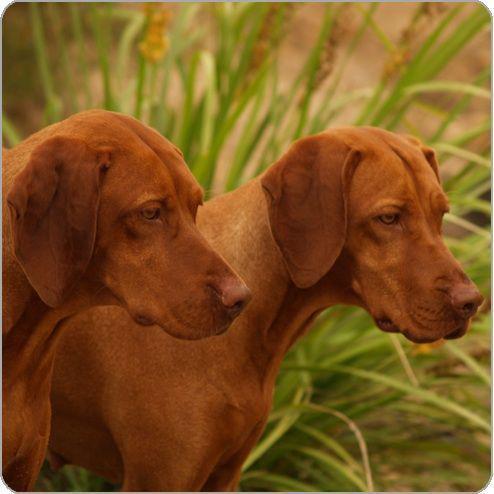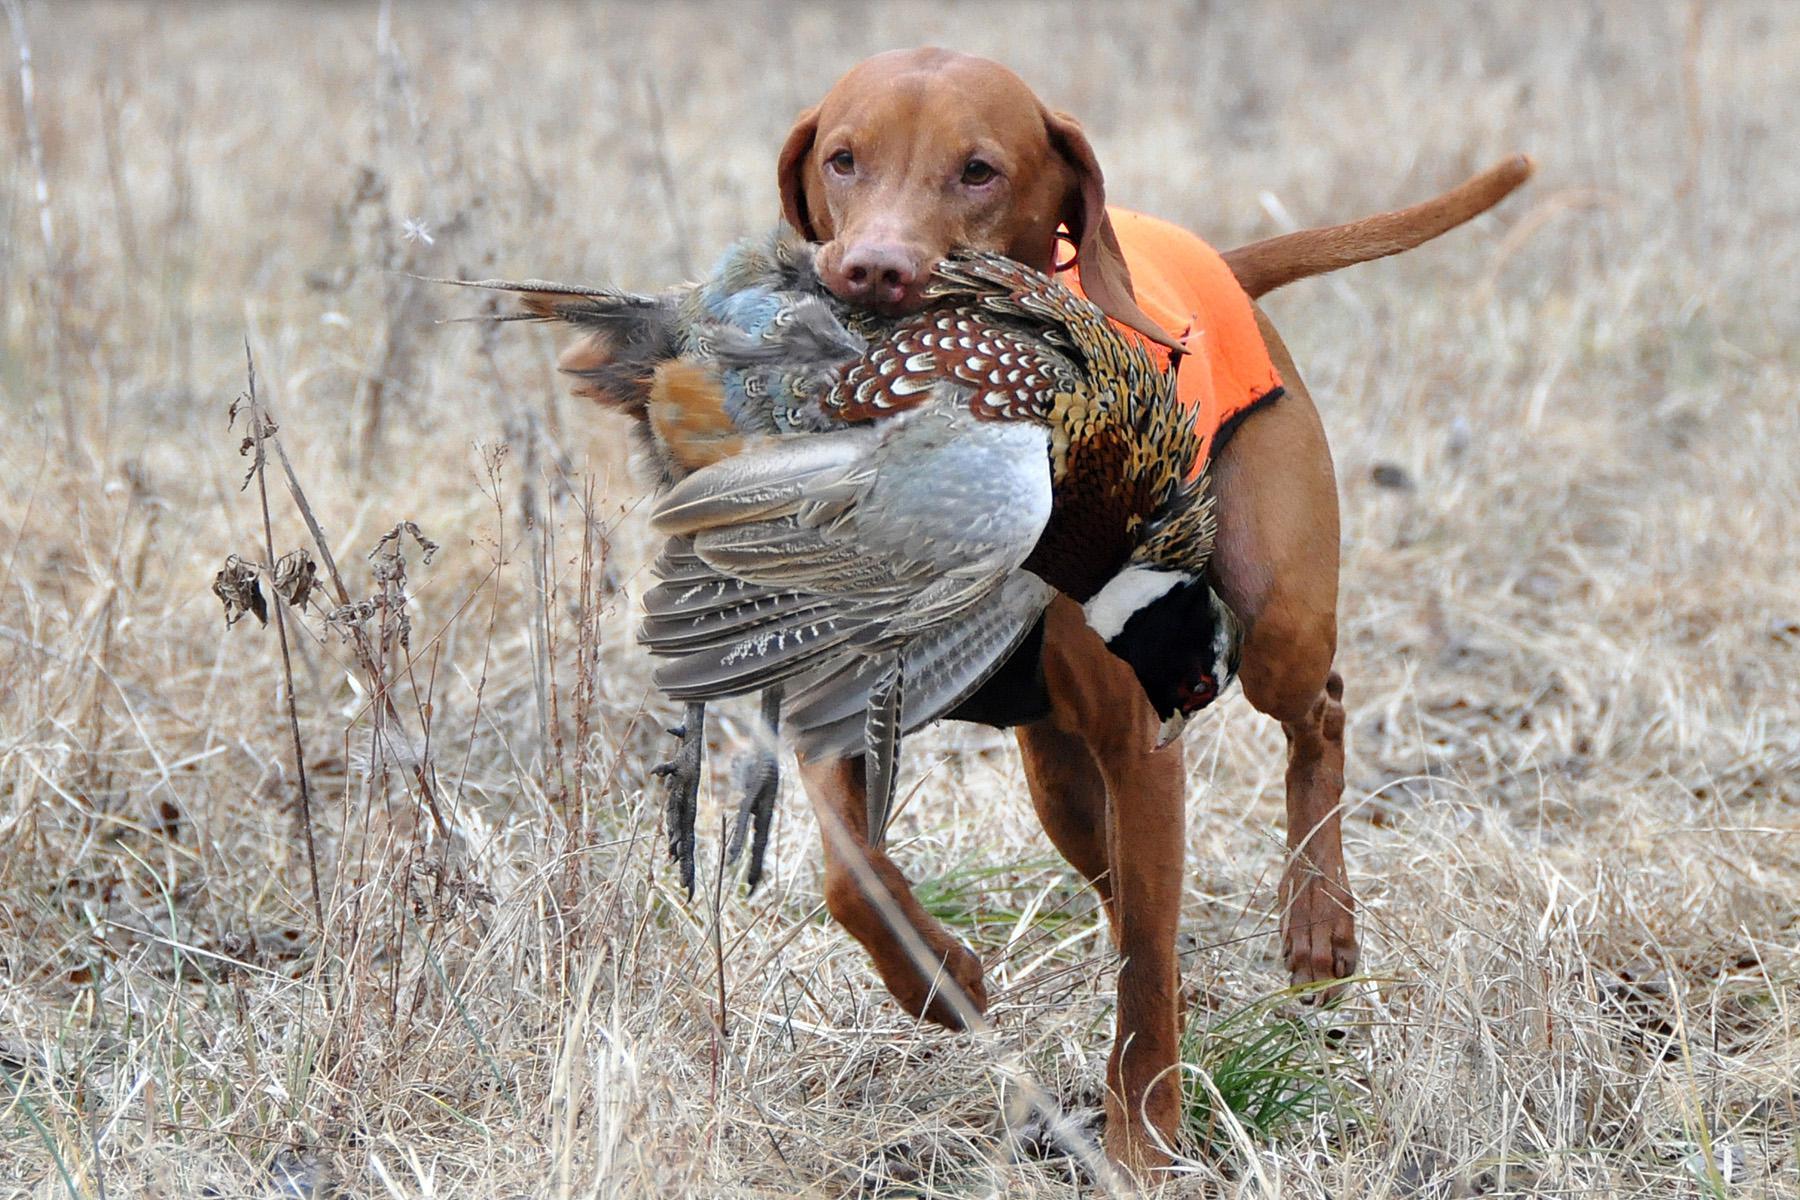The first image is the image on the left, the second image is the image on the right. Considering the images on both sides, is "There are only two dogs in the pair of images." valid? Answer yes or no. No. The first image is the image on the left, the second image is the image on the right. For the images shown, is this caption "All of the brown dogs are wearing collars." true? Answer yes or no. No. 